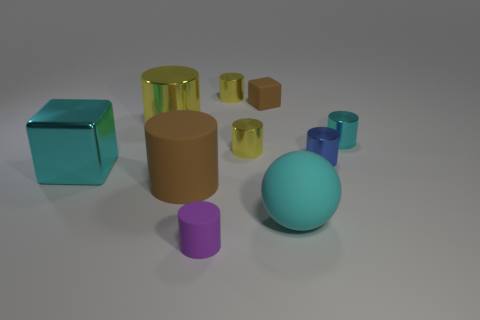Subtract all small yellow cylinders. How many cylinders are left? 5 Subtract 1 spheres. How many spheres are left? 0 Subtract all cyan blocks. How many blocks are left? 1 Subtract 0 red cubes. How many objects are left? 10 Subtract all cubes. How many objects are left? 8 Subtract all green cylinders. Subtract all purple cubes. How many cylinders are left? 7 Subtract all red cylinders. How many brown cubes are left? 1 Subtract all big rubber things. Subtract all big brown cylinders. How many objects are left? 7 Add 4 blue cylinders. How many blue cylinders are left? 5 Add 1 big green objects. How many big green objects exist? 1 